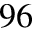Convert formula to latex. <formula><loc_0><loc_0><loc_500><loc_500>^ { 9 6 }</formula> 